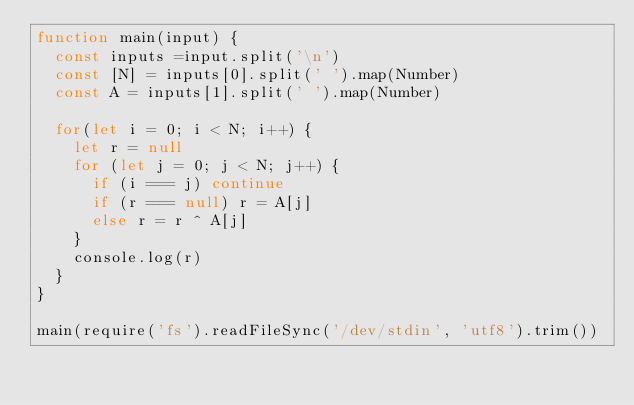<code> <loc_0><loc_0><loc_500><loc_500><_JavaScript_>function main(input) {
  const inputs =input.split('\n')
  const [N] = inputs[0].split(' ').map(Number)
  const A = inputs[1].split(' ').map(Number)

  for(let i = 0; i < N; i++) {
    let r = null
    for (let j = 0; j < N; j++) {
      if (i === j) continue
      if (r === null) r = A[j]
      else r = r ^ A[j]
    }
    console.log(r)
  }
}

main(require('fs').readFileSync('/dev/stdin', 'utf8').trim())
</code> 